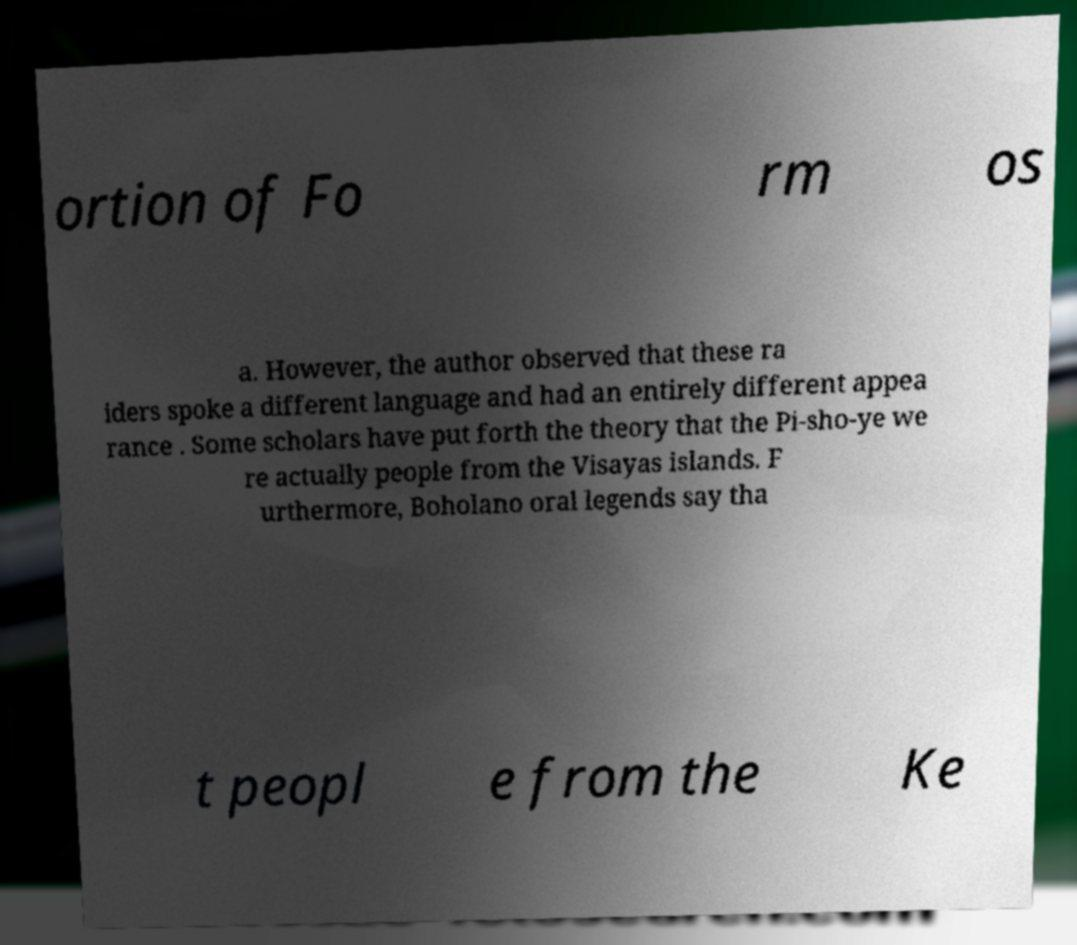For documentation purposes, I need the text within this image transcribed. Could you provide that? ortion of Fo rm os a. However, the author observed that these ra iders spoke a different language and had an entirely different appea rance . Some scholars have put forth the theory that the Pi-sho-ye we re actually people from the Visayas islands. F urthermore, Boholano oral legends say tha t peopl e from the Ke 